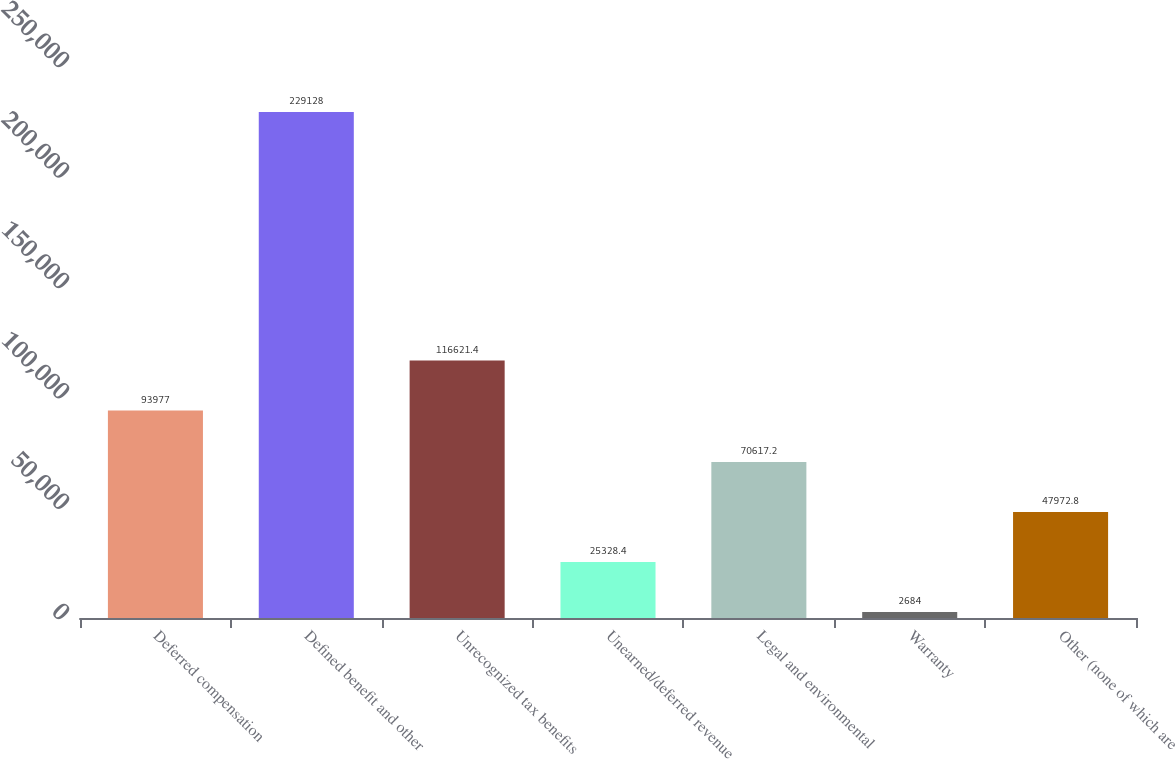Convert chart. <chart><loc_0><loc_0><loc_500><loc_500><bar_chart><fcel>Deferred compensation<fcel>Defined benefit and other<fcel>Unrecognized tax benefits<fcel>Unearned/deferred revenue<fcel>Legal and environmental<fcel>Warranty<fcel>Other (none of which are<nl><fcel>93977<fcel>229128<fcel>116621<fcel>25328.4<fcel>70617.2<fcel>2684<fcel>47972.8<nl></chart> 